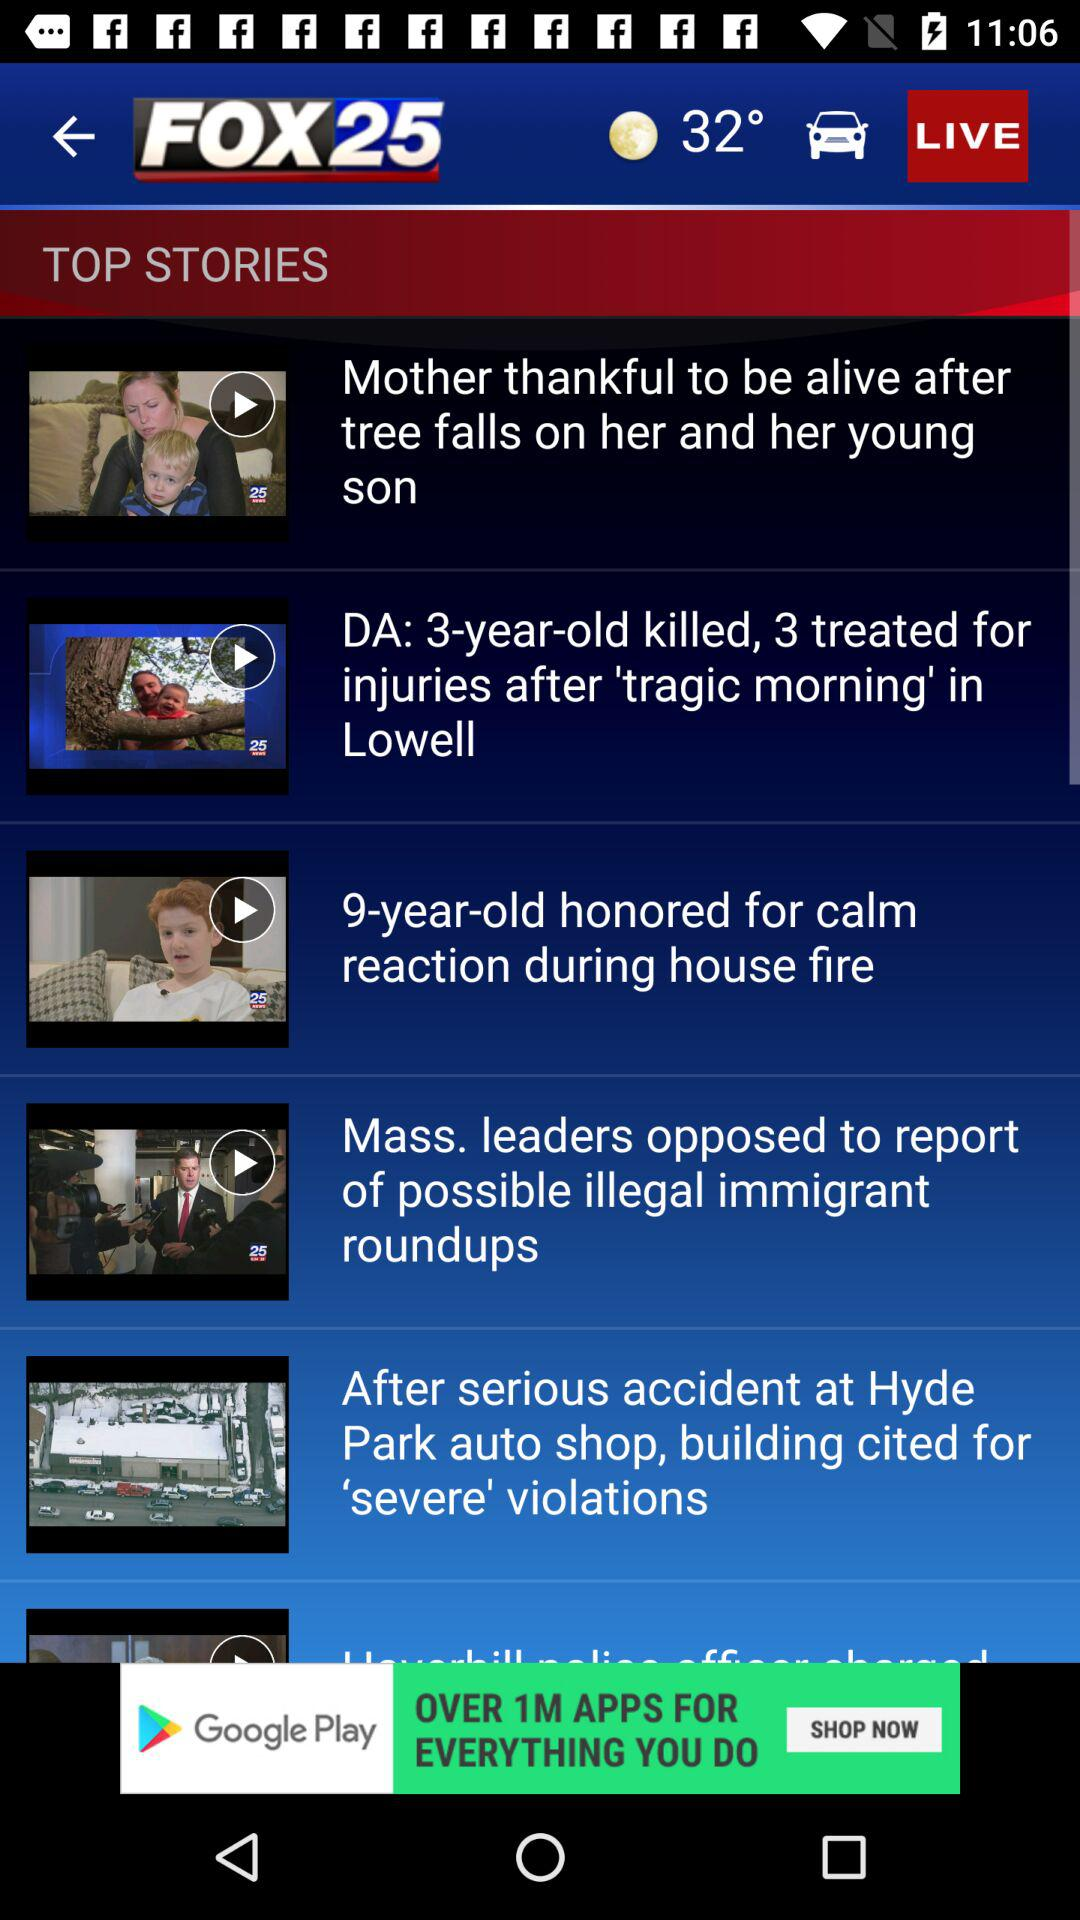What is the temperature? The temperature is 32°. 